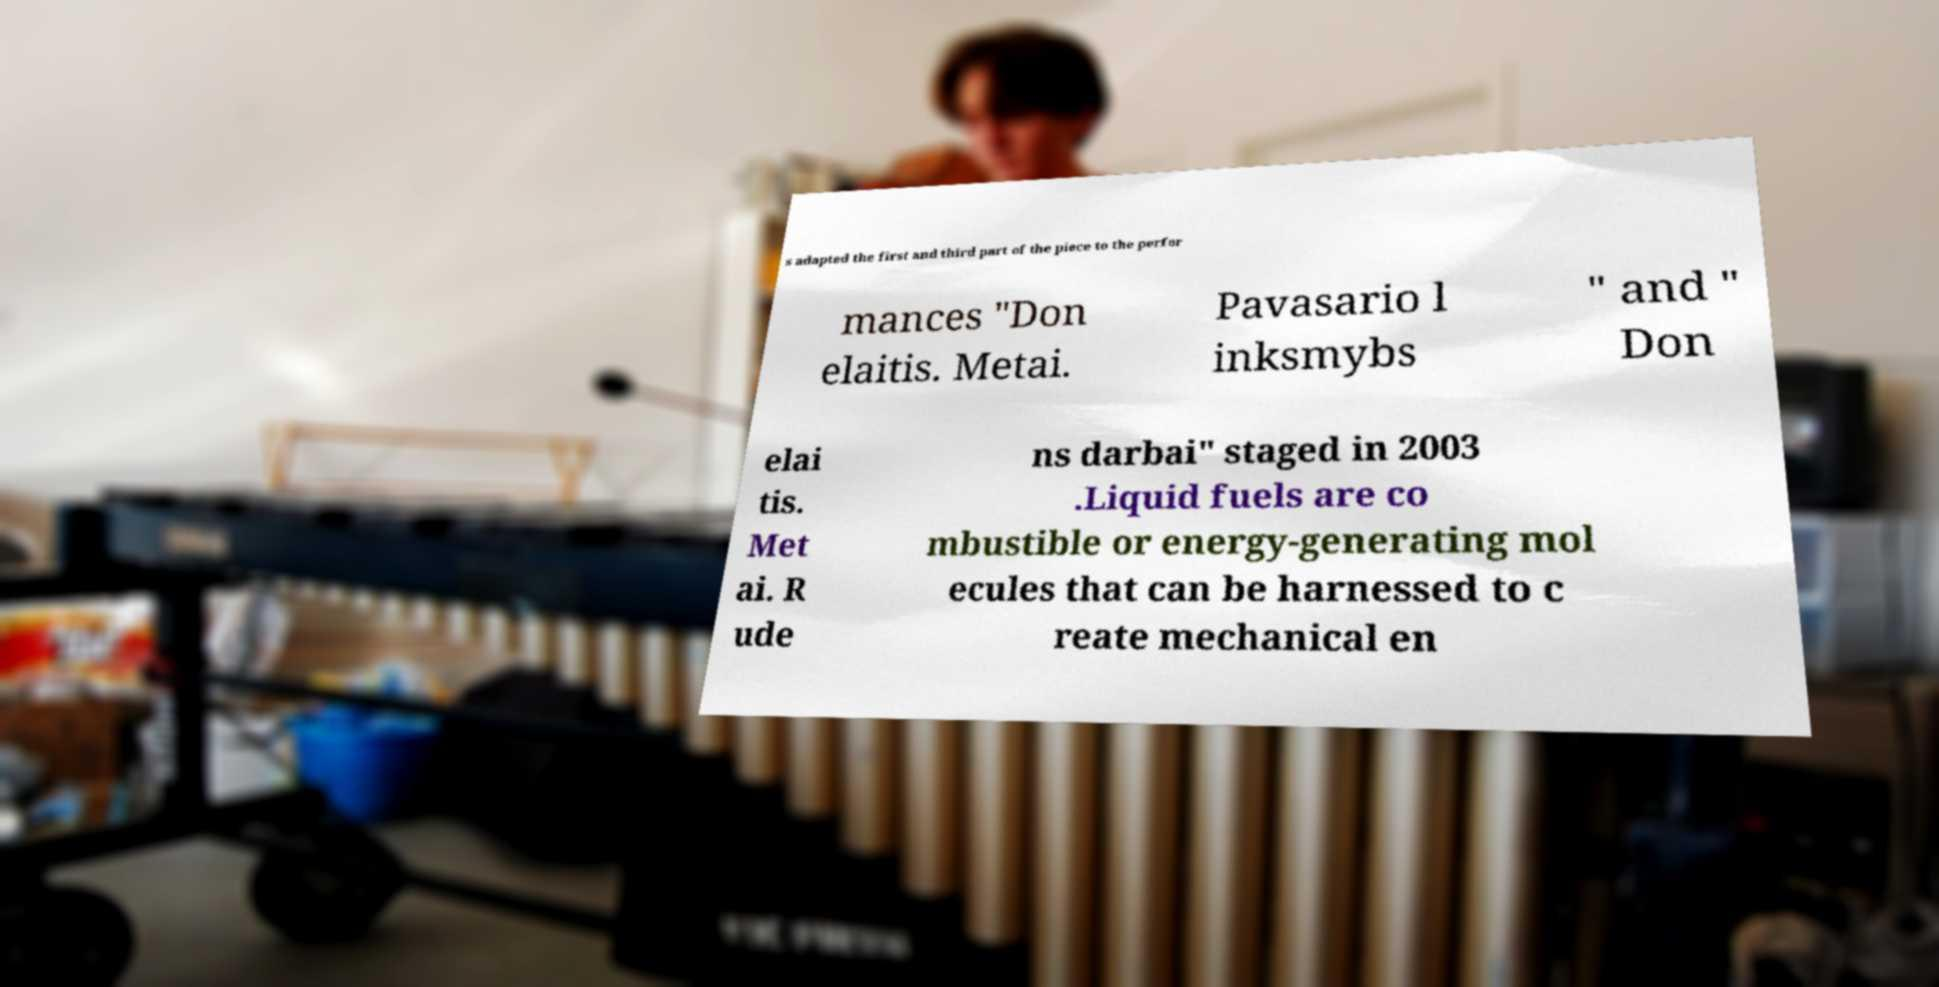Could you assist in decoding the text presented in this image and type it out clearly? s adapted the first and third part of the piece to the perfor mances "Don elaitis. Metai. Pavasario l inksmybs " and " Don elai tis. Met ai. R ude ns darbai" staged in 2003 .Liquid fuels are co mbustible or energy-generating mol ecules that can be harnessed to c reate mechanical en 